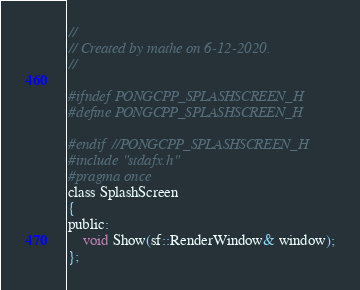<code> <loc_0><loc_0><loc_500><loc_500><_C_>//
// Created by mathe on 6-12-2020.
//

#ifndef PONGCPP_SPLASHSCREEN_H
#define PONGCPP_SPLASHSCREEN_H

#endif //PONGCPP_SPLASHSCREEN_H
#include "stdafx.h"
#pragma once
class SplashScreen
{
public:
    void Show(sf::RenderWindow& window);
};</code> 